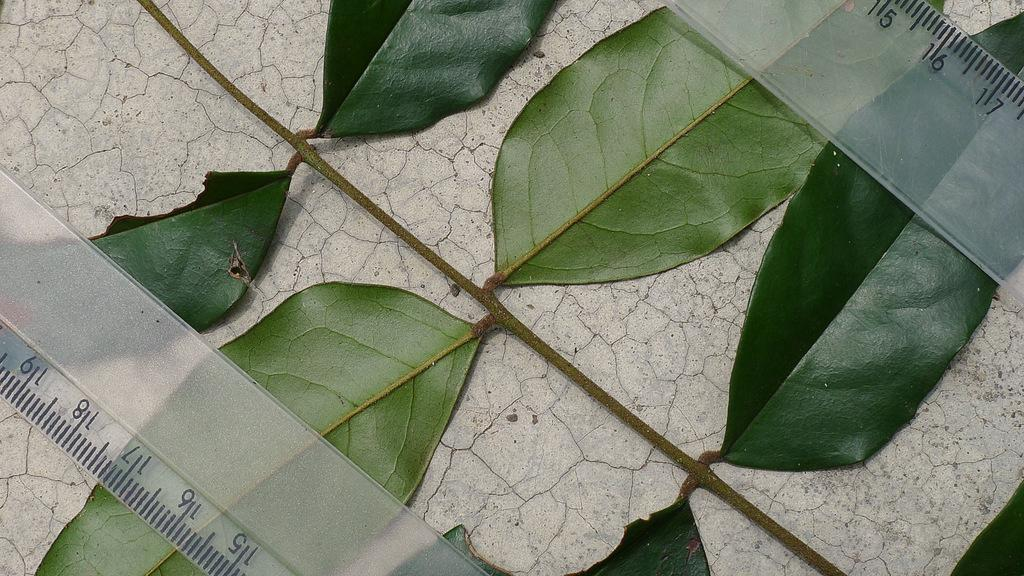What type of vegetation is present in the image? There are green leaves in the image. What objects can be seen on a platform in the image? There are two scales placed on a platform in the image. What type of finger painting can be seen on the canvas in the image? There is no canvas or finger painting present in the image. How many feet are visible in the image? There are no feet visible in the image. 